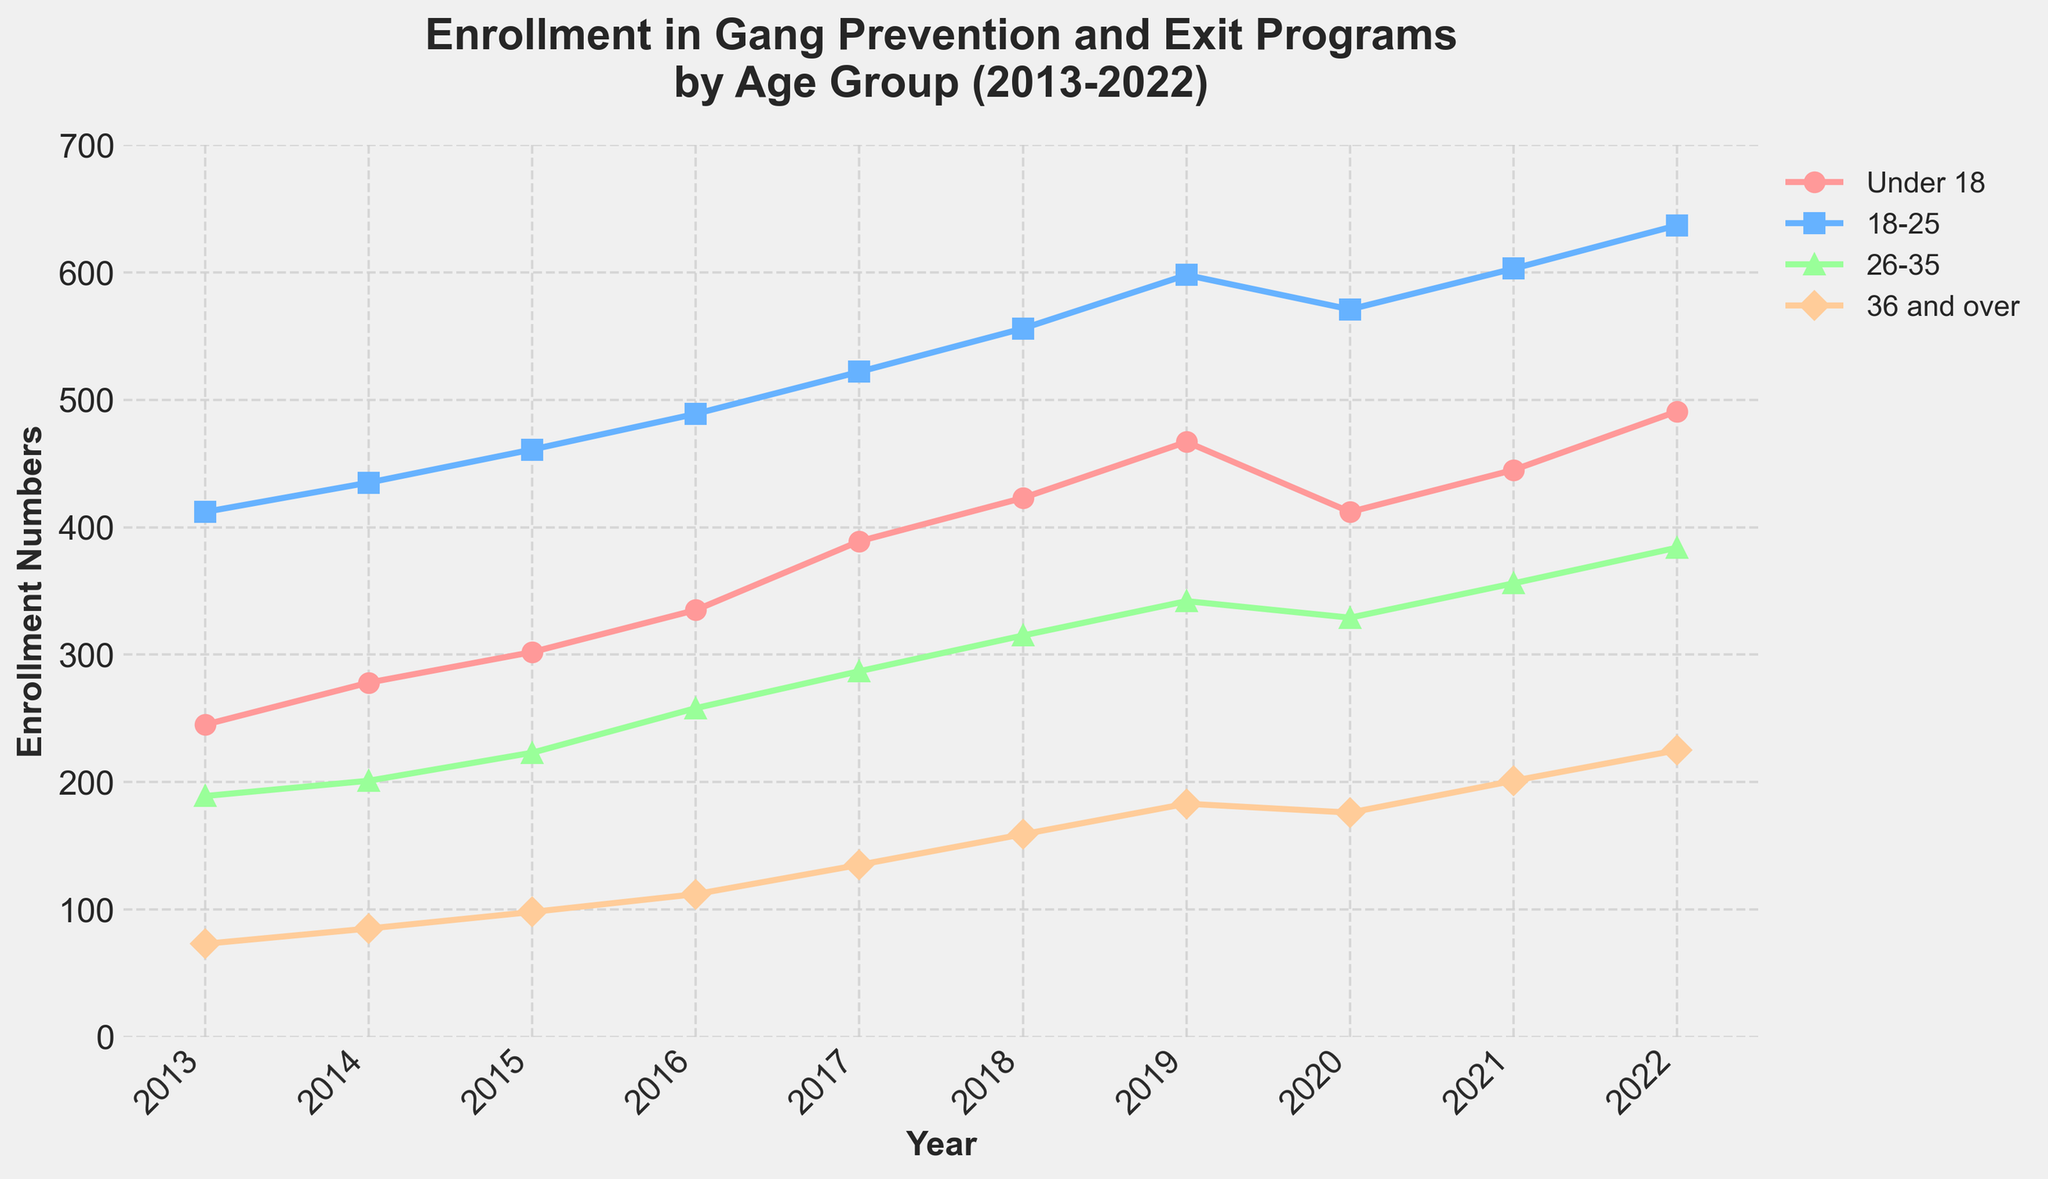What year had the highest enrollment for the "Under 18" group? Look at the "Under 18" line in the plot and identify the year with the highest point.
Answer: 2022 Which age group had the largest increase in enrollment from 2013 to 2022? Compare the end points of each age group's line for 2022 and 2013. Calculate the difference for each group and find the largest one. "Under 18" increased by (491-245), "18-25" by (637-412), "26-35" by (384-189), and "36 and over" by (225-73). The largest increase is "18-25".
Answer: 18-25 How does the enrollment number of the "36 and over" group in 2018 compare to the "26-35" group in the same year? Look at the points for the year 2018 on the lines for "36 and over" and "26-35". Compare their heights.
Answer: Lower What is the total enrollment number across all age groups in the year 2020? Add the enrollment numbers of all four age groups for 2020 from the plot. (412 + 571 + 329 + 176)
Answer: 1488 On average, how many people enrolled in programs each year in the "26-35" age group? Sum up the enrollment numbers for "26-35" across all years from 2013 to 2022 and divide by the number of years (10). (189+201+223+258+287+315+342+329+356+384)/10
Answer: 278.4 In which year did the "Under 18" group see the largest single-year increase in enrollment? Analyze the differences year-over-year for the "Under 18" group and identify the year with the largest increase by measuring the height differences between the points. (278-245 to 491-445). The largest increase was from 2021 to 2022.
Answer: 2022 What is the enrollment trend for the "18-25" age group? Observe the direction and slope of the "18-25" line throughout the years. For all years, it generally increases except for a slight dip in 2020.
Answer: Increasing Which age group had the smallest enrollment in 2016? Look at the enrollment numbers in 2016 for all four age groups and identify the smallest value. "Under 18" was 335, "18-25" was 489, "26-35" was 258, "36 and over" was 112. The smallest is "36 and over".
Answer: 36 and over What is the difference in enrollment between "18-25" and "26-35" in 2019? Subtract the 2019 enrollment number for "26-35" from that of "18-25" (598 - 342).
Answer: 256 By how much did the enrollment for the "Under 18" group change from 2019 to 2020? Subtract the 2020 figure for "Under 18" from the 2019 figure (467 - 412).
Answer: -55 